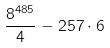Convert formula to latex. <formula><loc_0><loc_0><loc_500><loc_500>\frac { 8 ^ { 4 8 5 } } { 4 } - 2 5 7 \cdot 6</formula> 